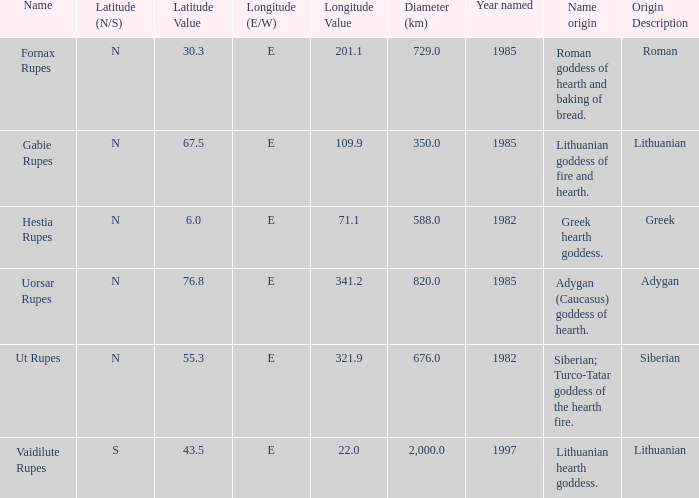In 1997, what was the diameter of the identified feature? 2000.0. 